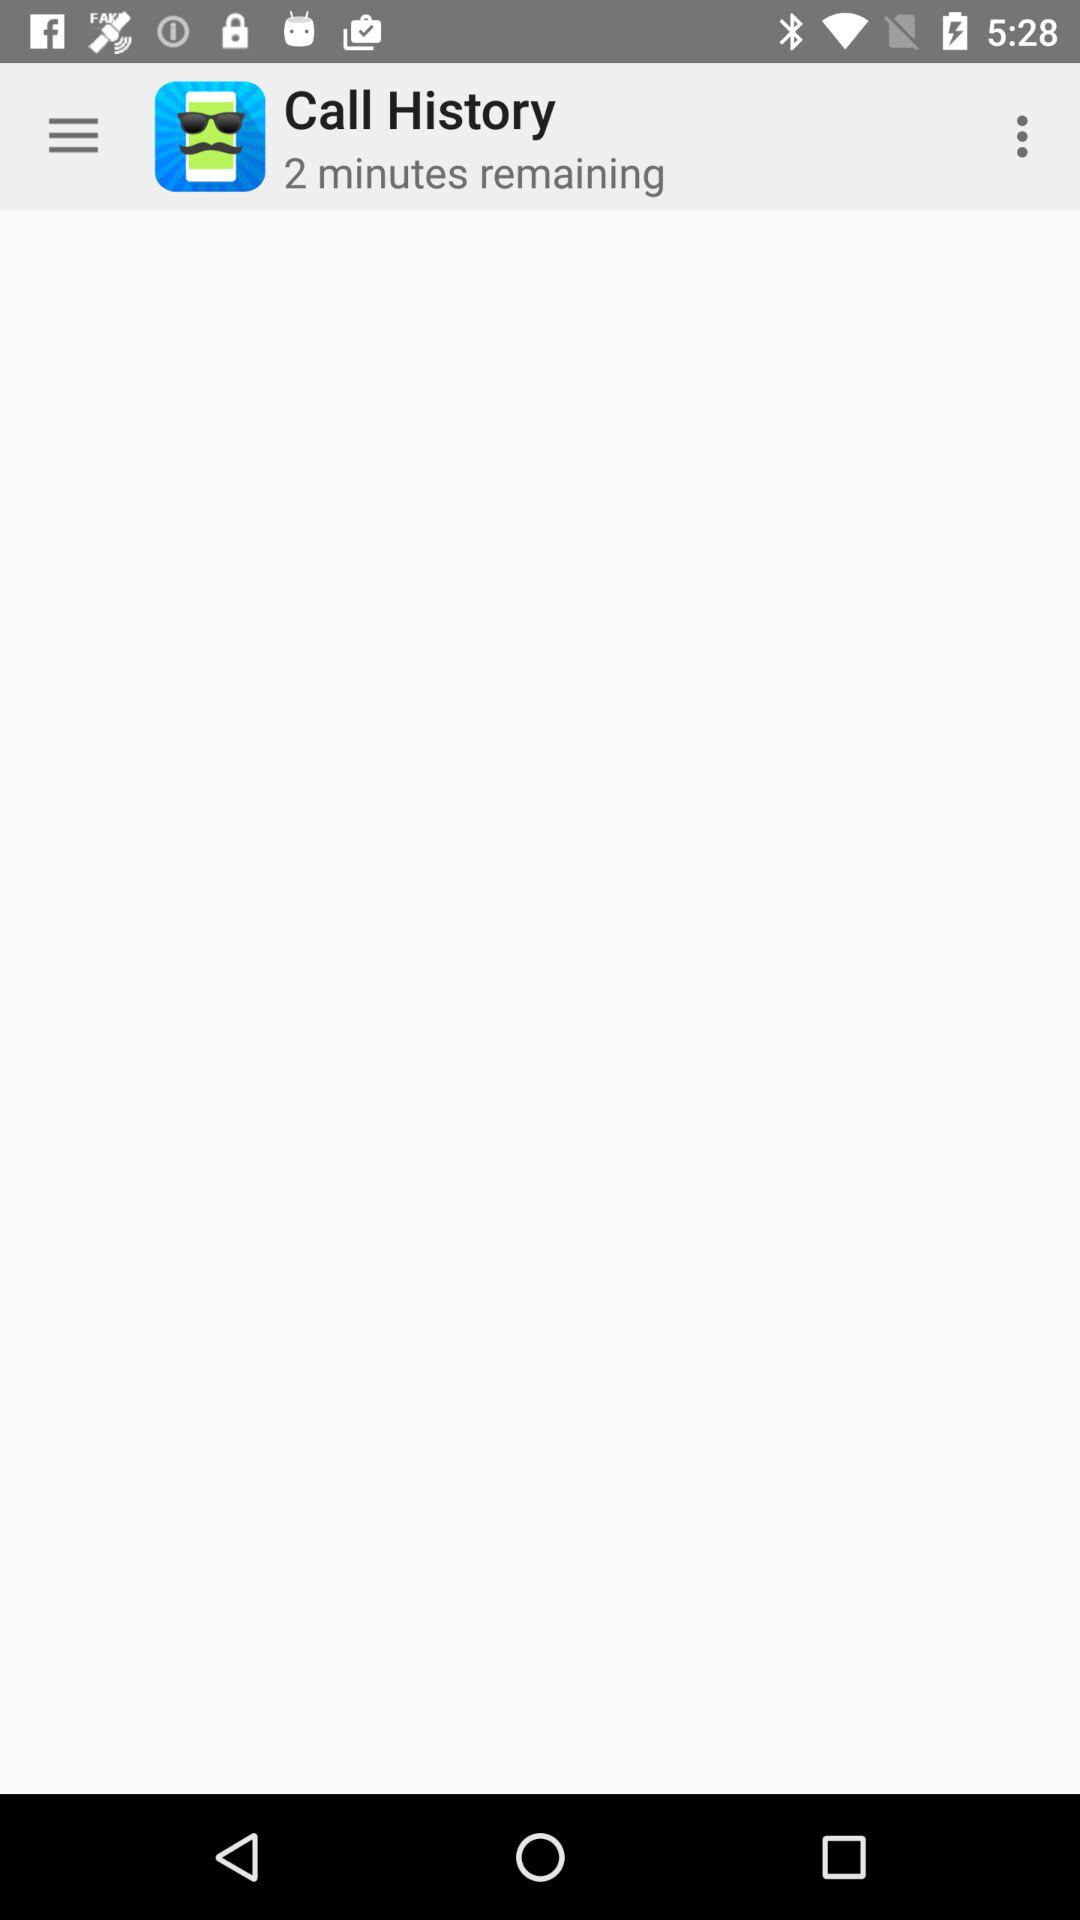What are the names of the people in my call history?
When the provided information is insufficient, respond with <no answer>. <no answer> 